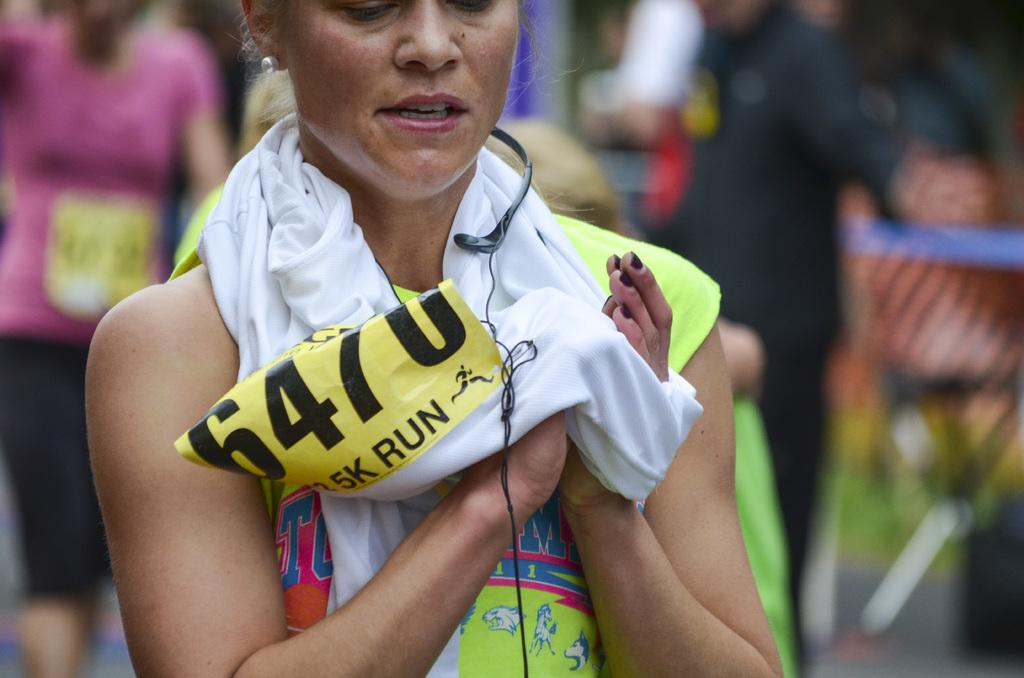<image>
Summarize the visual content of the image. A woman with the number 6470 wiping her hands with a towel 